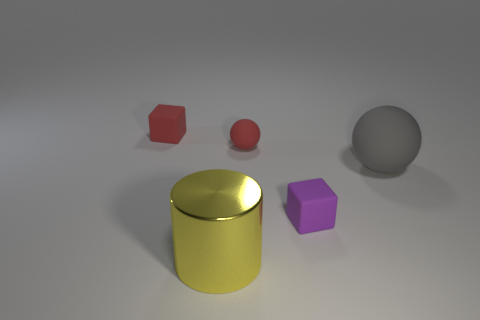Add 2 tiny purple objects. How many objects exist? 7 Subtract all blocks. How many objects are left? 3 Add 5 small purple blocks. How many small purple blocks are left? 6 Add 4 cyan metal cylinders. How many cyan metal cylinders exist? 4 Subtract 1 gray spheres. How many objects are left? 4 Subtract all brown matte objects. Subtract all yellow metallic cylinders. How many objects are left? 4 